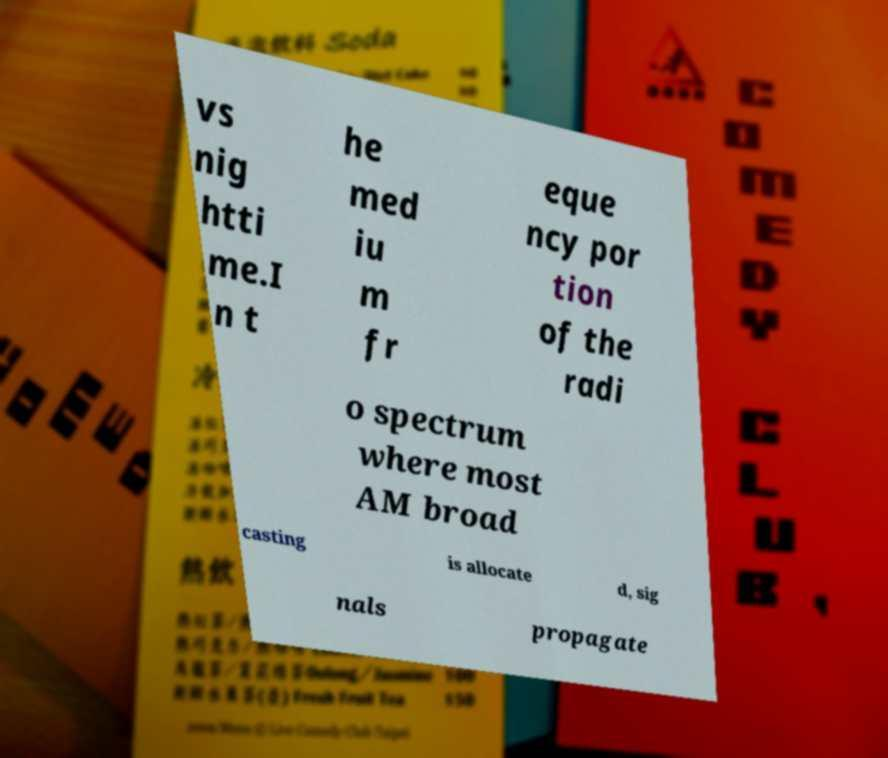Please read and relay the text visible in this image. What does it say? vs nig htti me.I n t he med iu m fr eque ncy por tion of the radi o spectrum where most AM broad casting is allocate d, sig nals propagate 